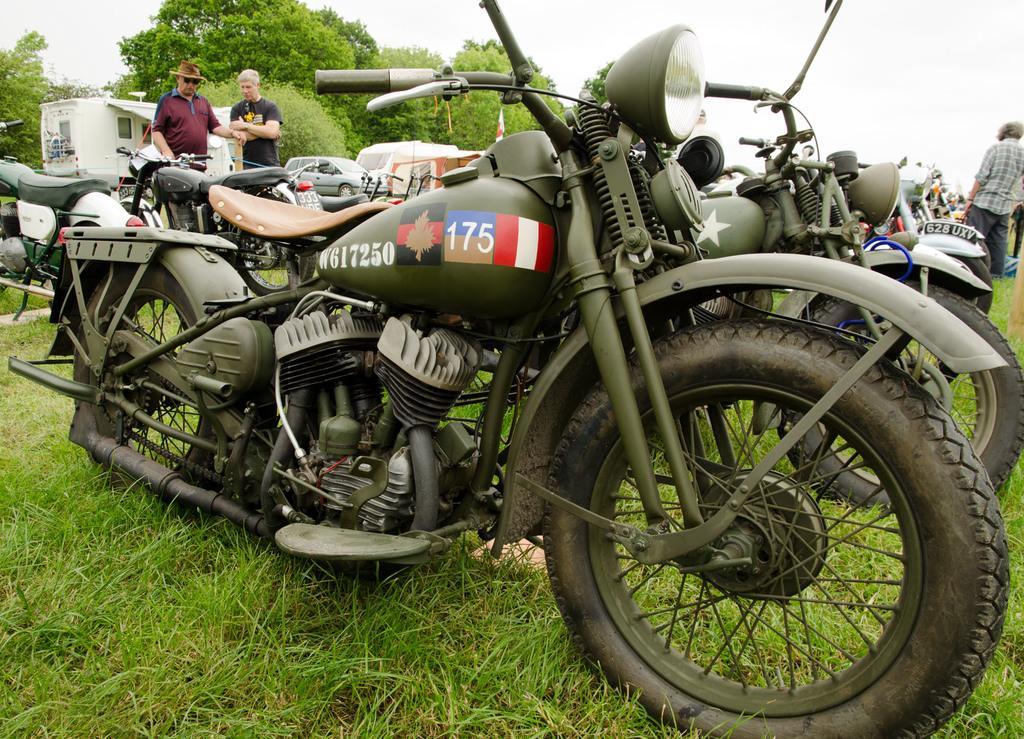Describe this image in one or two sentences. In the center of the image we can see the vehicles. In the background of the image we can see the trees, grass, house, flags and some people are standing. At the bottom of the image we can see the ground. At the top of the image we can see the sky. 